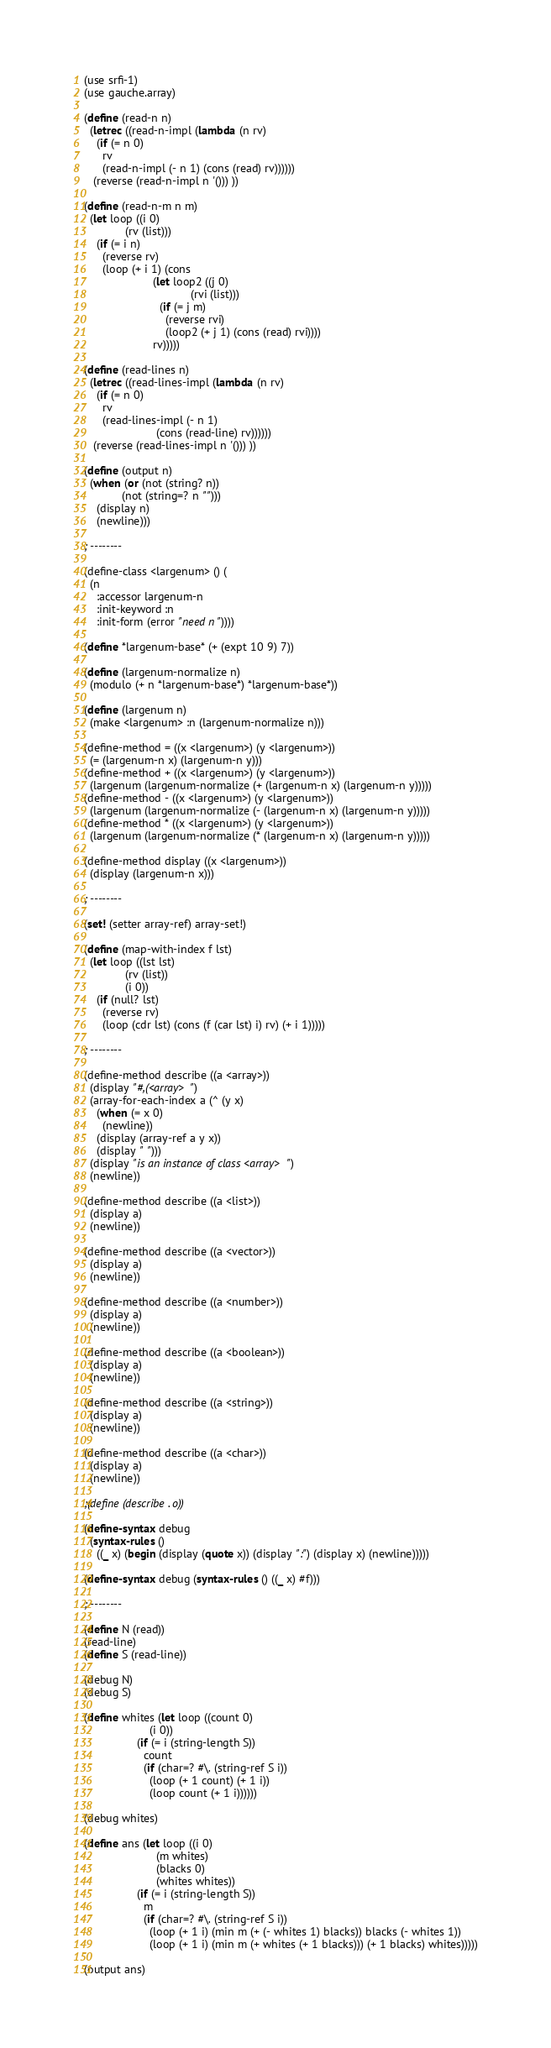Convert code to text. <code><loc_0><loc_0><loc_500><loc_500><_Scheme_>(use srfi-1)
(use gauche.array)

(define (read-n n)
  (letrec ((read-n-impl (lambda (n rv)
    (if (= n 0)
      rv
      (read-n-impl (- n 1) (cons (read) rv))))))
   (reverse (read-n-impl n '())) ))

(define (read-n-m n m)
  (let loop ((i 0)
             (rv (list)))
    (if (= i n)
      (reverse rv)
      (loop (+ i 1) (cons 
                      (let loop2 ((j 0)
                                  (rvi (list)))
                        (if (= j m)
                          (reverse rvi)
                          (loop2 (+ j 1) (cons (read) rvi))))
                      rv)))))

(define (read-lines n)
  (letrec ((read-lines-impl (lambda (n rv)
    (if (= n 0)
      rv
      (read-lines-impl (- n 1)
                       (cons (read-line) rv))))))
   (reverse (read-lines-impl n '())) ))

(define (output n)
  (when (or (not (string? n))
            (not (string=? n "")))
    (display n) 
    (newline)))

; --------

(define-class <largenum> () (
  (n
    :accessor largenum-n
    :init-keyword :n
    :init-form (error "need n"))))

(define *largenum-base* (+ (expt 10 9) 7))

(define (largenum-normalize n)
  (modulo (+ n *largenum-base*) *largenum-base*))

(define (largenum n)
  (make <largenum> :n (largenum-normalize n)))

(define-method = ((x <largenum>) (y <largenum>))
  (= (largenum-n x) (largenum-n y)))
(define-method + ((x <largenum>) (y <largenum>))
  (largenum (largenum-normalize (+ (largenum-n x) (largenum-n y)))))
(define-method - ((x <largenum>) (y <largenum>))
  (largenum (largenum-normalize (- (largenum-n x) (largenum-n y)))))
(define-method * ((x <largenum>) (y <largenum>))
  (largenum (largenum-normalize (* (largenum-n x) (largenum-n y)))))

(define-method display ((x <largenum>))
  (display (largenum-n x)))

; --------

(set! (setter array-ref) array-set!)

(define (map-with-index f lst)
  (let loop ((lst lst)
             (rv (list))
             (i 0))
    (if (null? lst)
      (reverse rv)
      (loop (cdr lst) (cons (f (car lst) i) rv) (+ i 1)))))

; --------

(define-method describe ((a <array>))
  (display "#,(<array> ")
  (array-for-each-index a (^ (y x)
    (when (= x 0)
      (newline))
    (display (array-ref a y x))
    (display " ")))
  (display "is an instance of class <array>")
  (newline))

(define-method describe ((a <list>))
  (display a)
  (newline))

(define-method describe ((a <vector>))
  (display a)
  (newline))

(define-method describe ((a <number>))
  (display a)
  (newline))

(define-method describe ((a <boolean>))
  (display a)
  (newline))

(define-method describe ((a <string>))
  (display a)
  (newline))

(define-method describe ((a <char>))
  (display a)
  (newline))

;(define (describe . o))

(define-syntax debug
  (syntax-rules ()
    ((_ x) (begin (display (quote x)) (display ":") (display x) (newline)))))

(define-syntax debug (syntax-rules () ((_ x) #f))) 

; --------

(define N (read))
(read-line)
(define S (read-line))

(debug N)
(debug S)

(define whites (let loop ((count 0)
                     (i 0))
                 (if (= i (string-length S))
                   count
                   (if (char=? #\. (string-ref S i))
                     (loop (+ 1 count) (+ 1 i))
                     (loop count (+ 1 i))))))

(debug whites)

(define ans (let loop ((i 0)
                       (m whites)
                       (blacks 0)
                       (whites whites))
                 (if (= i (string-length S))
                   m
                   (if (char=? #\. (string-ref S i))
                     (loop (+ 1 i) (min m (+ (- whites 1) blacks)) blacks (- whites 1))
                     (loop (+ 1 i) (min m (+ whites (+ 1 blacks))) (+ 1 blacks) whites)))))

(output ans)
</code> 